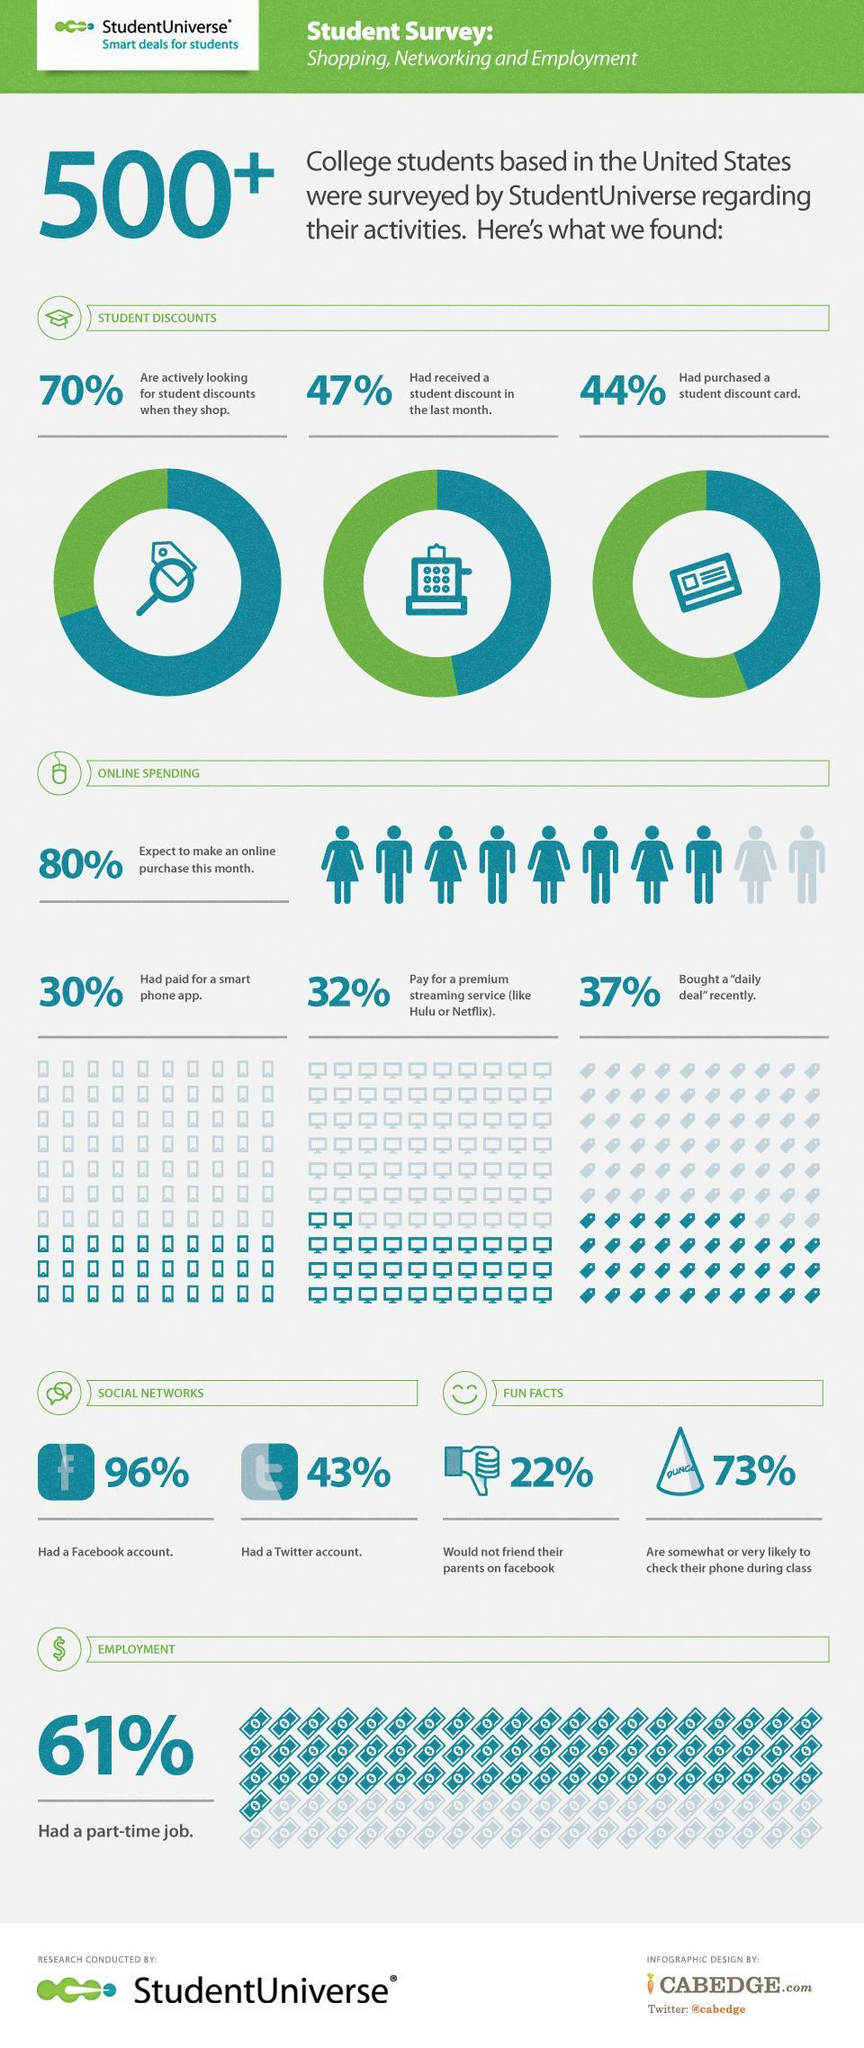What percentage of students did not purchase daily deal recently?
Answer the question with a short phrase. 63 What percent of students do not have Facebook account? 4 What percentage of students did not purchase a discount card? 56 What percentage of students will not make a purchase in the current month? 20 What percentage of students already have a twitter account? 43% What percentage of students do not look for student discount card when they shop? 30 What percentage of students have no part time job? 39 What percentage of students did not receive Student discount in the previous month? 53 What percentage of students did not accept their parents friend request? 22% 